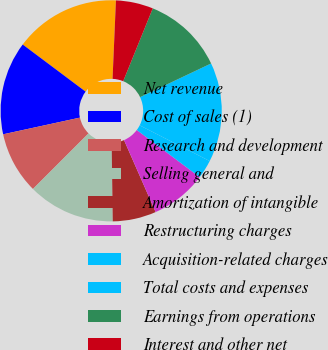Convert chart. <chart><loc_0><loc_0><loc_500><loc_500><pie_chart><fcel>Net revenue<fcel>Cost of sales (1)<fcel>Research and development<fcel>Selling general and<fcel>Amortization of intangible<fcel>Restructuring charges<fcel>Acquisition-related charges<fcel>Total costs and expenses<fcel>Earnings from operations<fcel>Interest and other net<nl><fcel>15.45%<fcel>13.64%<fcel>9.09%<fcel>12.73%<fcel>6.36%<fcel>8.18%<fcel>2.73%<fcel>14.55%<fcel>11.82%<fcel>5.45%<nl></chart> 